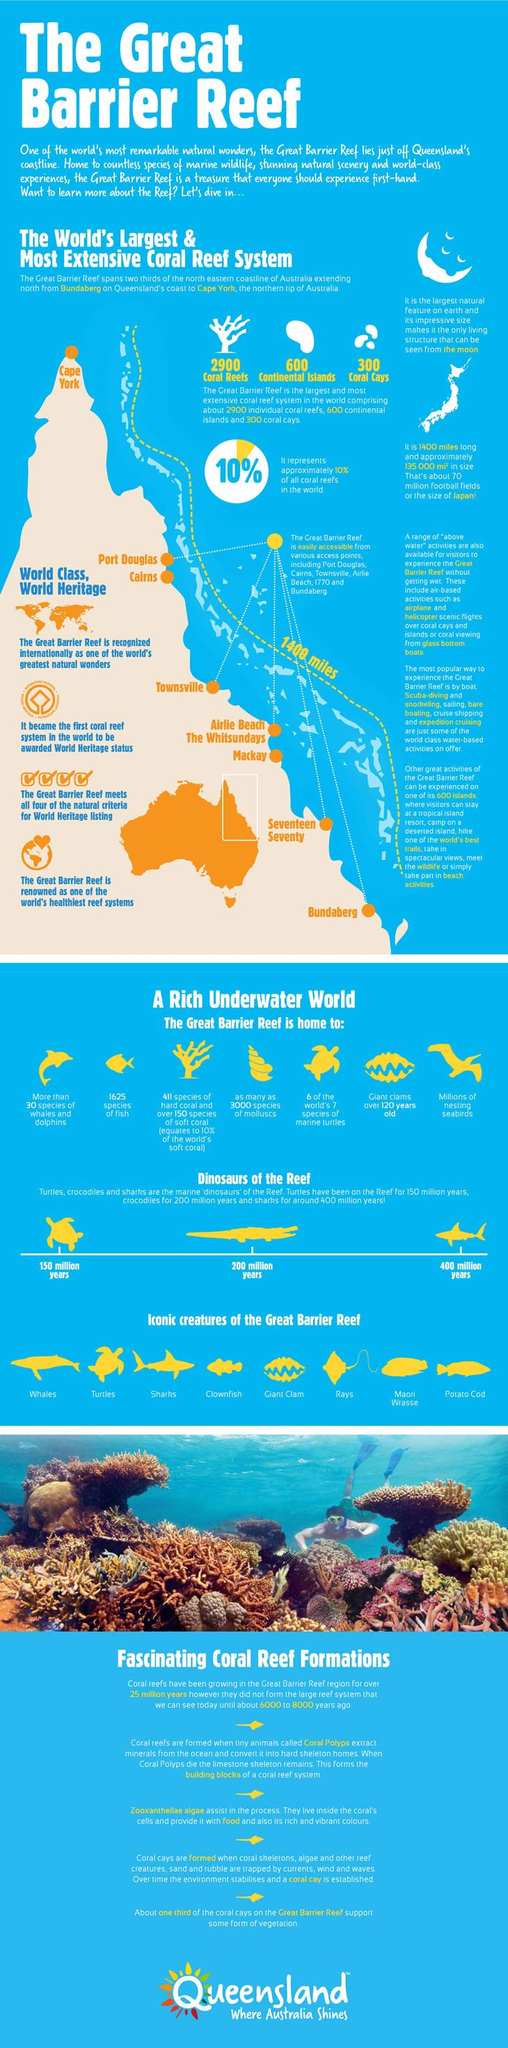Give some essential details in this illustration. There are a total of 8 access points. The dinosaur of the reef that has been in the reef for the longest period is sharks. There are approximately 600 continental islands in the world. The access point located at the tip of the reef is Cape York. Japan is a large country with a size equivalent to that of The Great Barrier Reef. 